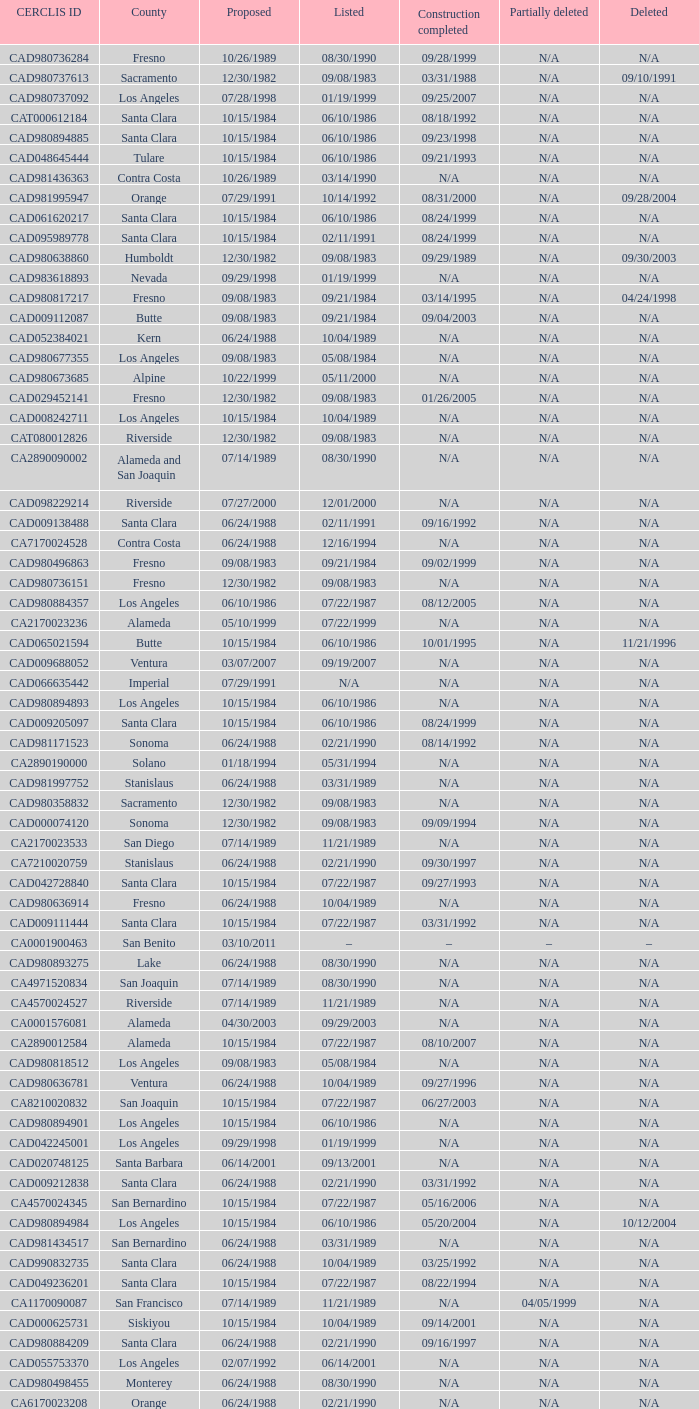What construction completed on 08/10/2007? 07/22/1987. 